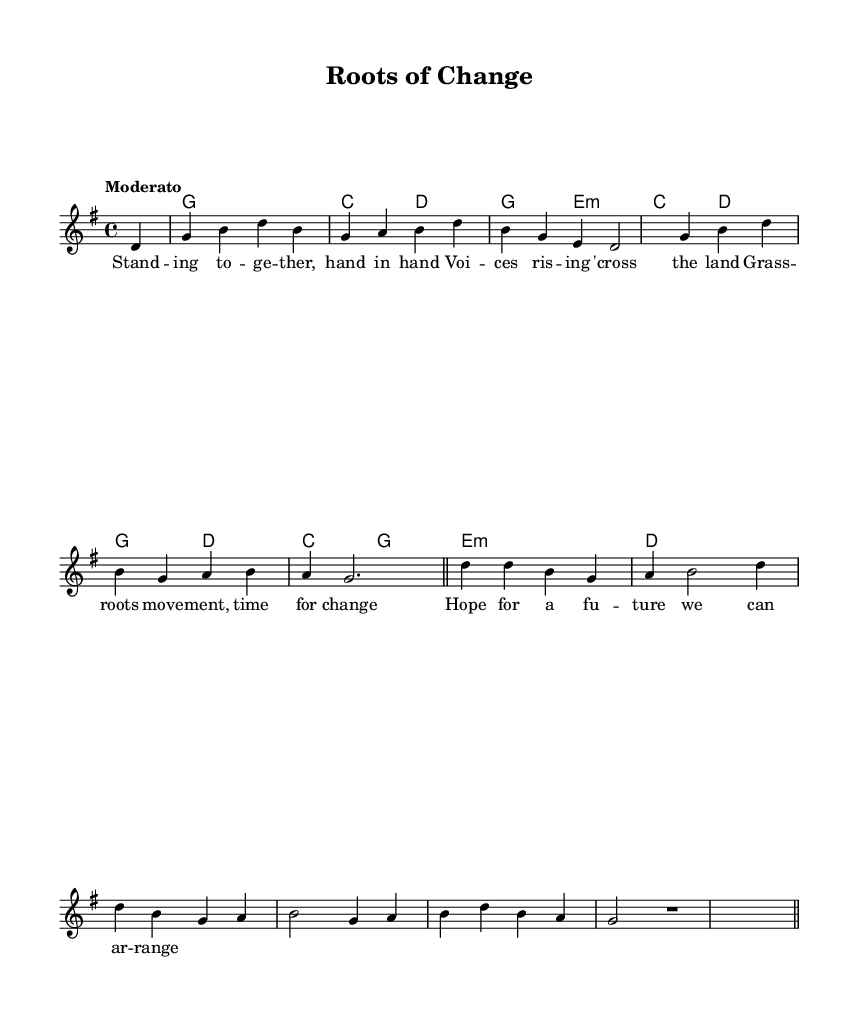What is the key signature of this music? The key signature is G major, indicated by one sharp (F#) in the music notation. This is evident from the global section at the beginning of the score where \key g \major is specified.
Answer: G major What is the time signature of this music? The time signature is 4/4, which means there are four beats per measure. This is clearly stated in the global section with \time 4/4.
Answer: 4/4 What is the tempo marking of this piece? The tempo marking is "Moderato," which suggests a moderate or moderate-paced tempo. This is shown in the global section where \tempo "Moderato" is included.
Answer: Moderato How many measures are there in the melody? There are 8 measures in the melody. By counting the vertical bar lines in the melody section, we can determine the number of distinct measures.
Answer: 8 What is the emotional theme conveyed in the lyrics? The lyrics convey a sense of hope and unity, focusing on togetherness and grassroots movements for change. This can be interpreted from the lyric lines that emphasize standing together and hoping for a future.
Answer: Hope and unity What harmonic structure is most prominent in the chord progression? The chord progression predominantly features the G major chord followed by transitions through the C major and D major chords, highlighting typical country-folk harmonic movement. This can be identified by analyzing the chords listed in the harmonies section.
Answer: G major In what musical genre does this piece fit? This piece fits the Country-folk fusion genre, as indicated by its blend of traditional country elements with folk themes, particularly in the lyrics and instrumentation styles implied by the chord structure.
Answer: Country-folk fusion 